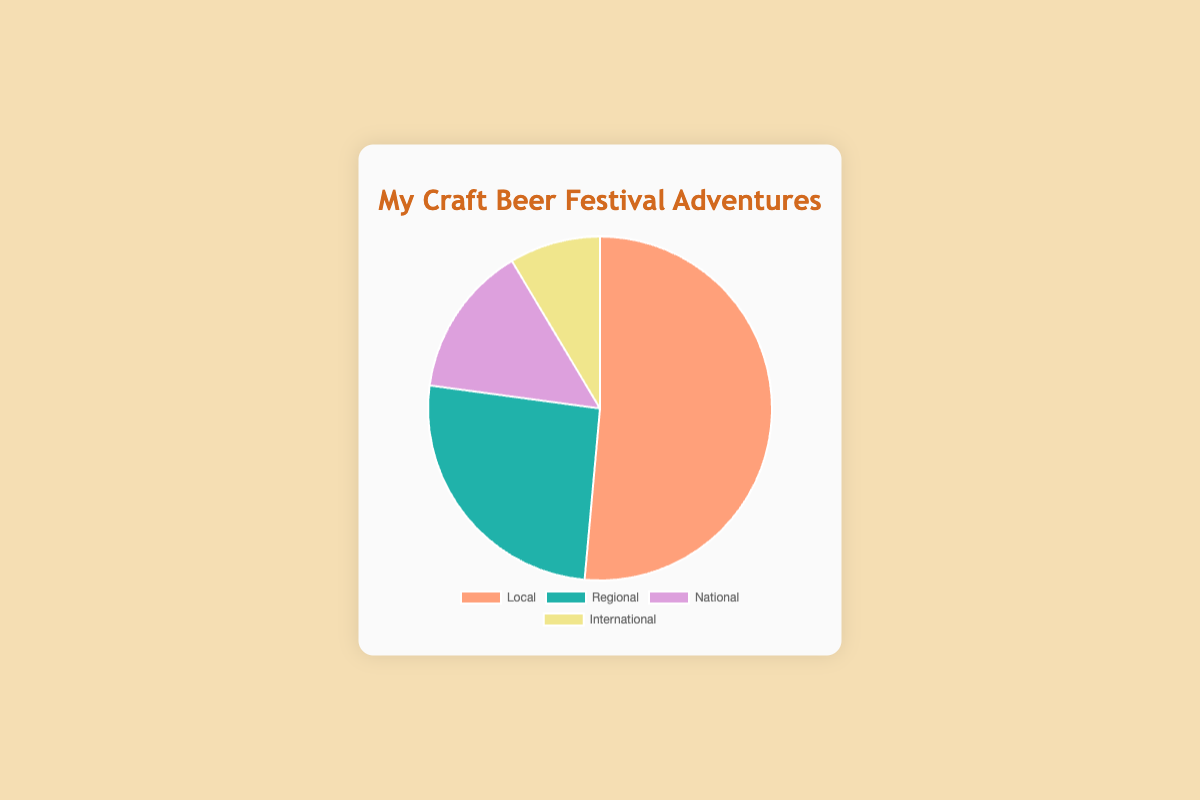What's the largest category of beer festivals you've attended? The largest category is the one with the most data points. By looking at the pie chart, the "Local" category has the largest portion with 18 festivals.
Answer: Local Which category has the fewest beer festivals attended? The category with the fewest festivals is the one with the smallest portion in the pie chart. "International" has the smallest portion with 3 festivals.
Answer: International What's the total number of Regional and National beer festivals you've attended? To get the total, add the number of Regional and National festivals: 9 (Regional) + 5 (National) = 14.
Answer: 14 How many more Local festivals have you attended compared to International ones? To find the difference between Local and International festivals, subtract the number of International festivals from the number of Local festivals: 18 (Local) - 3 (International) = 15.
Answer: 15 What color represents the Regional beer festivals in the pie chart? By referring to the colors shown in the chart, the color representing Regional beer festivals is the second color, which is "green".
Answer: Green Which is greater: The sum of National and International festivals or the number of Local festivals? First, sum the National and International festivals: 5 (National) + 3 (International) = 8. Then, compare this sum to the Local festivals: 8 (sum) < 18 (Local), so the number of Local festivals is greater.
Answer: Local festivals What's the average number of festivals attended in the Local and Regional categories combined? To find the average, first sum the number of Local and Regional festivals: 18 (Local) + 9 (Regional) = 27. Then, divide by the number of categories (2): 27 / 2 = 13.5.
Answer: 13.5 How does the number of National festivals compare to half the number of Local festivals? First, find half the number of Local festivals: 18 / 2 = 9. Then compare this to the number of National festivals, which is 5. Since 5 < 9, the number of National festivals is less than half the number of Local festivals.
Answer: Less What proportion of the total festivals attended are International? Calculate the total number of festivals: 18 (Local) + 9 (Regional) + 5 (National) + 3 (International) = 35. Then, find the proportion: 3 (International) / 35 (Total) ≈ 0.086 or 8.6%.
Answer: 8.6% Which category is represented by the purple segment in the pie chart? By referring to the colors associated with each category, the purple segment represents the "National" beer festivals.
Answer: National 